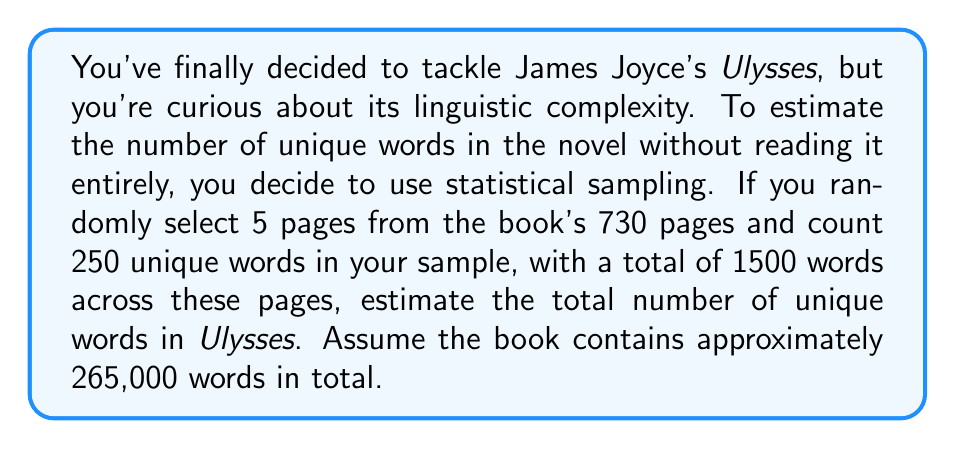Could you help me with this problem? Let's approach this step-by-step using statistical sampling:

1) First, calculate the sampling ratio:
   $5 \text{ pages} / 730 \text{ pages} = 1/146$

2) Calculate the words per page in our sample:
   $1500 \text{ words} / 5 \text{ pages} = 300 \text{ words per page}$

3) Estimate total pages based on total words:
   $265,000 \text{ total words} / 300 \text{ words per page} \approx 883 \text{ pages}$

4) Calculate the proportion of unique words in our sample:
   $250 \text{ unique words} / 1500 \text{ total words} = 1/6$

5) Estimate unique words in the entire book:
   $265,000 \text{ total words} \times (1/6) = 44,167 \text{ unique words}$

However, this is likely an underestimate. In a larger sample, we'd expect to find more unique words. We can apply a correction factor using the Good-Turing frequency estimation:

$$N_1 = N \cdot (1 - (1-p)^n)$$

Where:
$N_1$ = estimated number of unique words in the entire text
$N$ = total number of unique words in the language (let's estimate 100,000 for English)
$p$ = proportion of the text sampled ($1/146$)
$n$ = number of unique words in our sample (250)

Plugging in these values:

$$N_1 = 100,000 \cdot (1 - (1-1/146)^{250}) \approx 82,191$$

This gives us a more realistic estimate of the number of unique words in Ulysses.
Answer: Approximately 82,200 unique words 